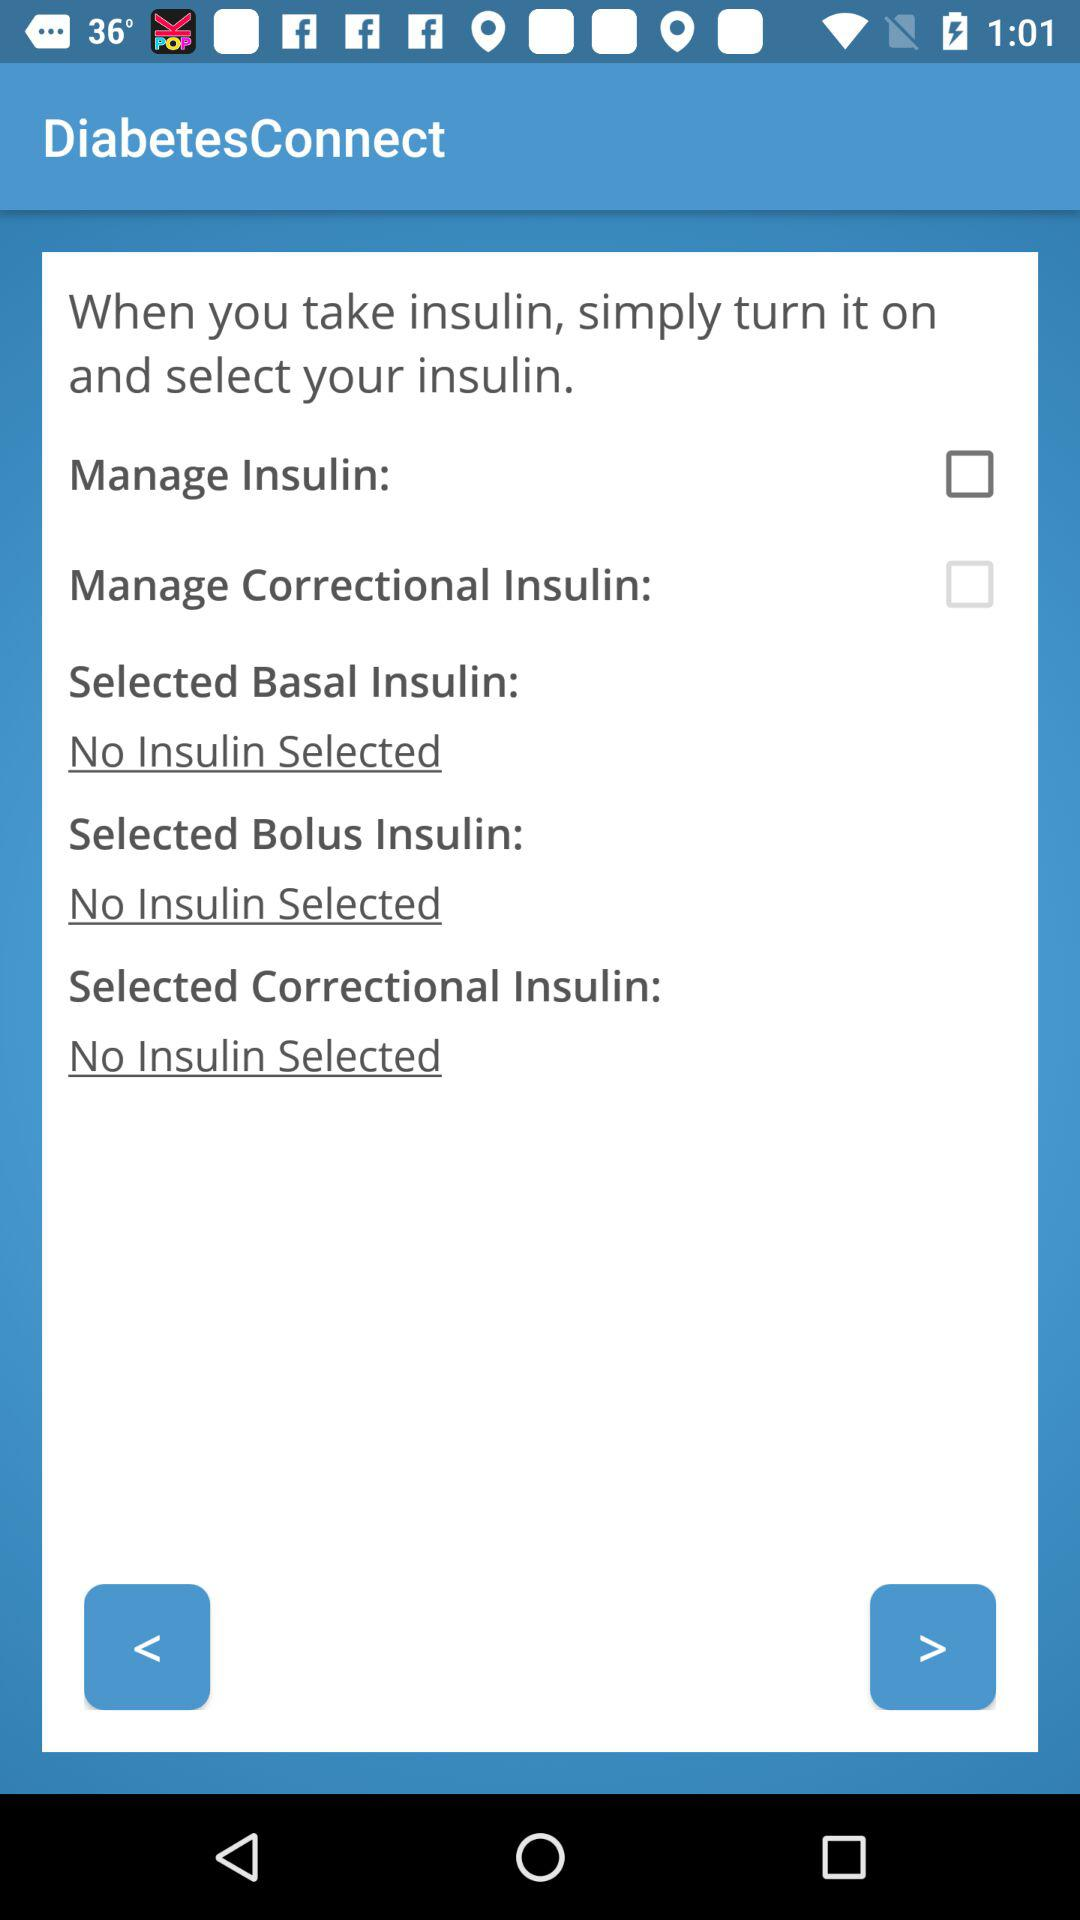What is the status of the "Manage Insulin"? The status is "off". 